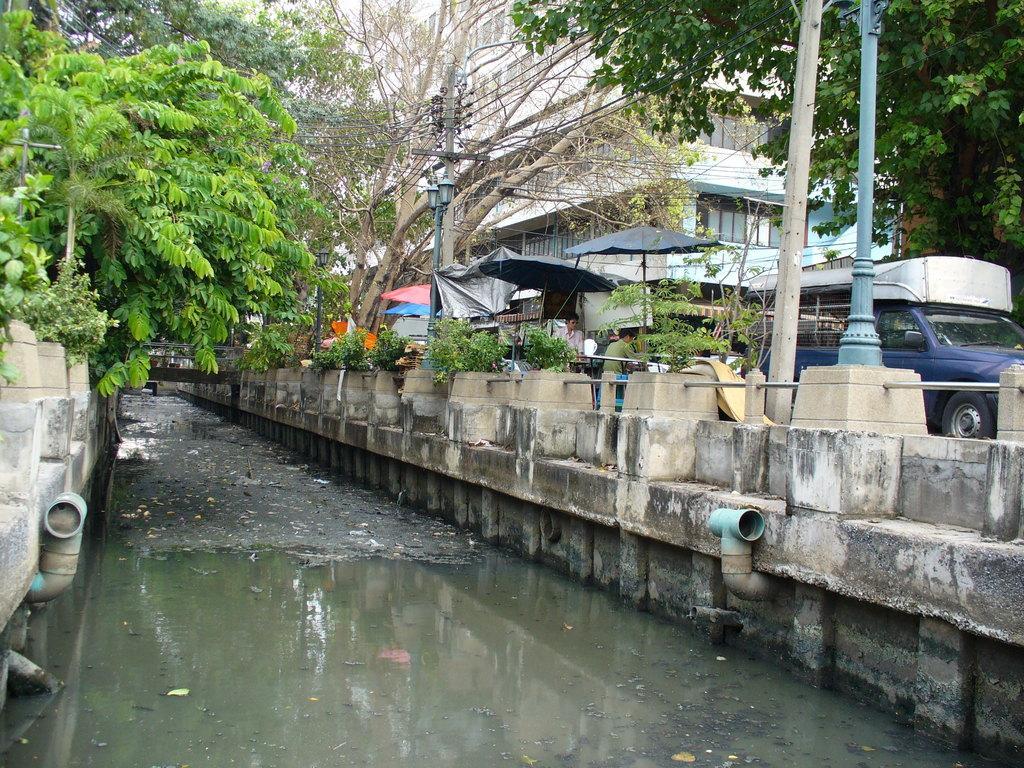In one or two sentences, can you explain what this image depicts? There is water, it seems like boundaries in the foreground area of the image, there are trees, people, vehicles, stalls, poles and buildings in the background. 